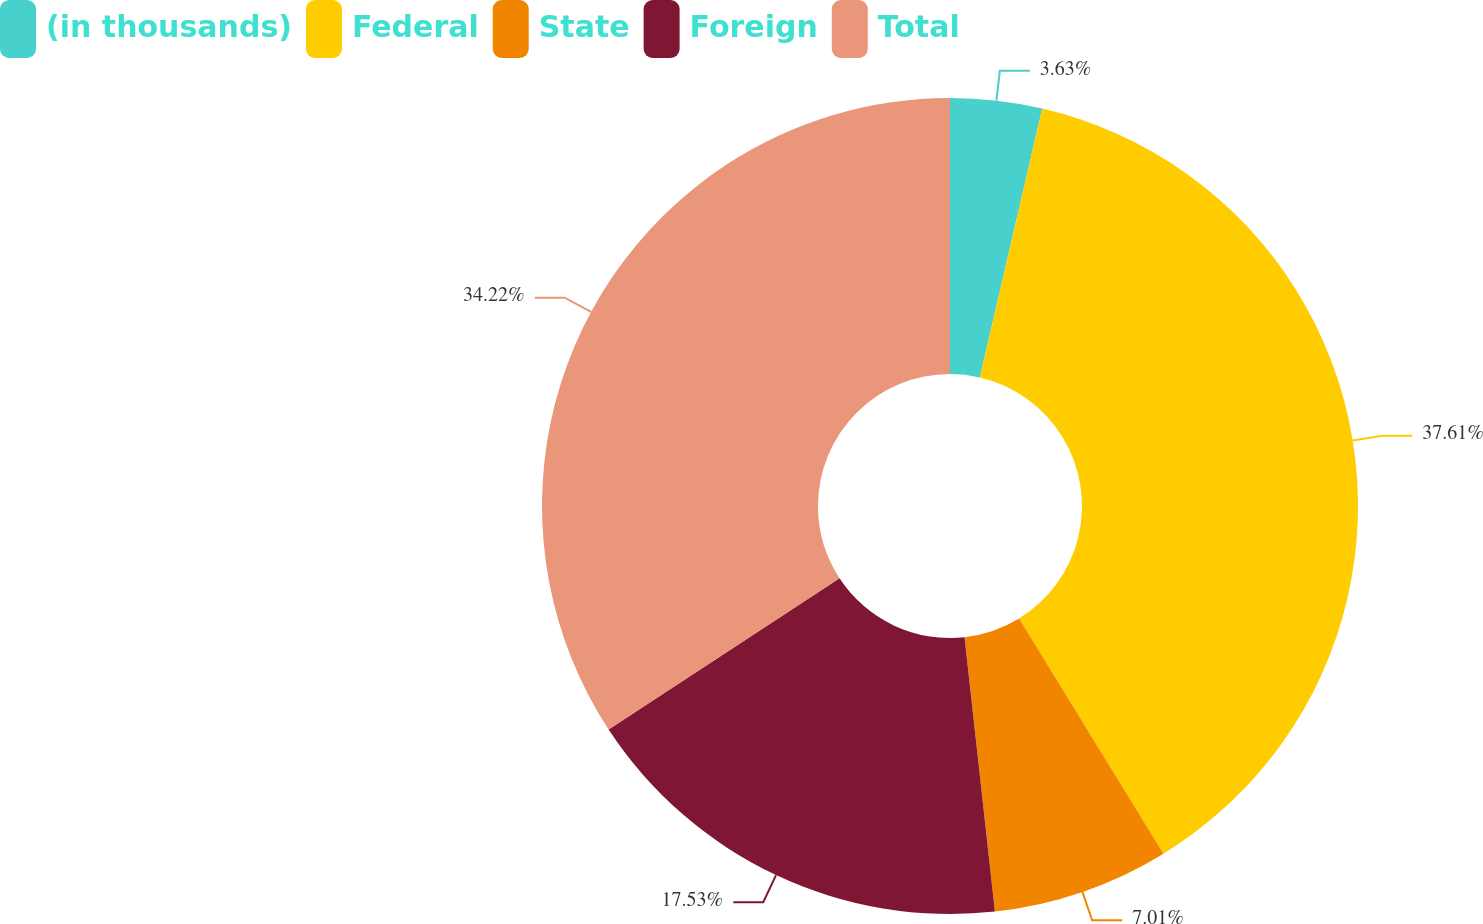Convert chart to OTSL. <chart><loc_0><loc_0><loc_500><loc_500><pie_chart><fcel>(in thousands)<fcel>Federal<fcel>State<fcel>Foreign<fcel>Total<nl><fcel>3.63%<fcel>37.6%<fcel>7.01%<fcel>17.53%<fcel>34.22%<nl></chart> 